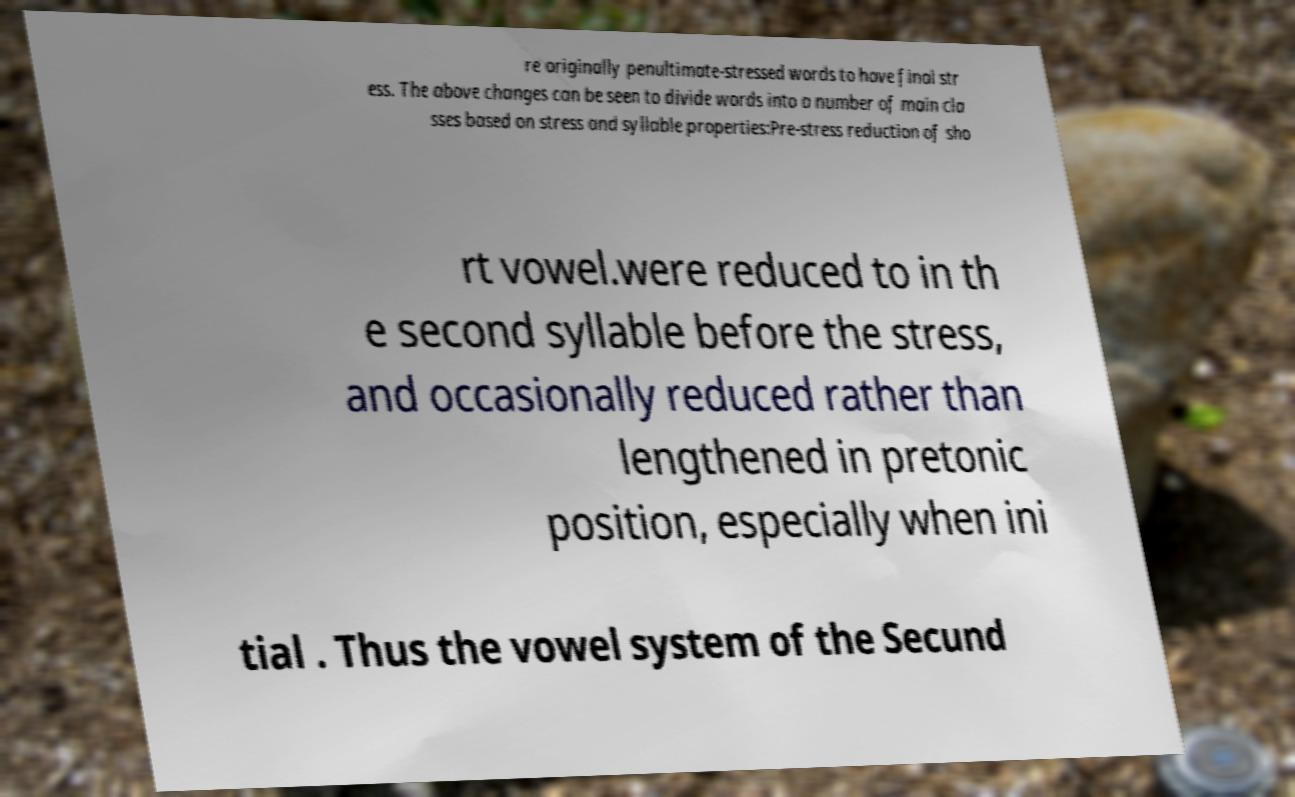For documentation purposes, I need the text within this image transcribed. Could you provide that? re originally penultimate-stressed words to have final str ess. The above changes can be seen to divide words into a number of main cla sses based on stress and syllable properties:Pre-stress reduction of sho rt vowel.were reduced to in th e second syllable before the stress, and occasionally reduced rather than lengthened in pretonic position, especially when ini tial . Thus the vowel system of the Secund 